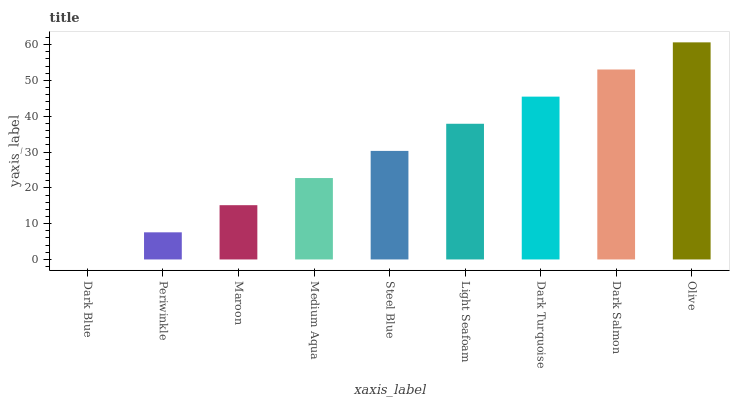Is Periwinkle the minimum?
Answer yes or no. No. Is Periwinkle the maximum?
Answer yes or no. No. Is Periwinkle greater than Dark Blue?
Answer yes or no. Yes. Is Dark Blue less than Periwinkle?
Answer yes or no. Yes. Is Dark Blue greater than Periwinkle?
Answer yes or no. No. Is Periwinkle less than Dark Blue?
Answer yes or no. No. Is Steel Blue the high median?
Answer yes or no. Yes. Is Steel Blue the low median?
Answer yes or no. Yes. Is Dark Blue the high median?
Answer yes or no. No. Is Dark Salmon the low median?
Answer yes or no. No. 